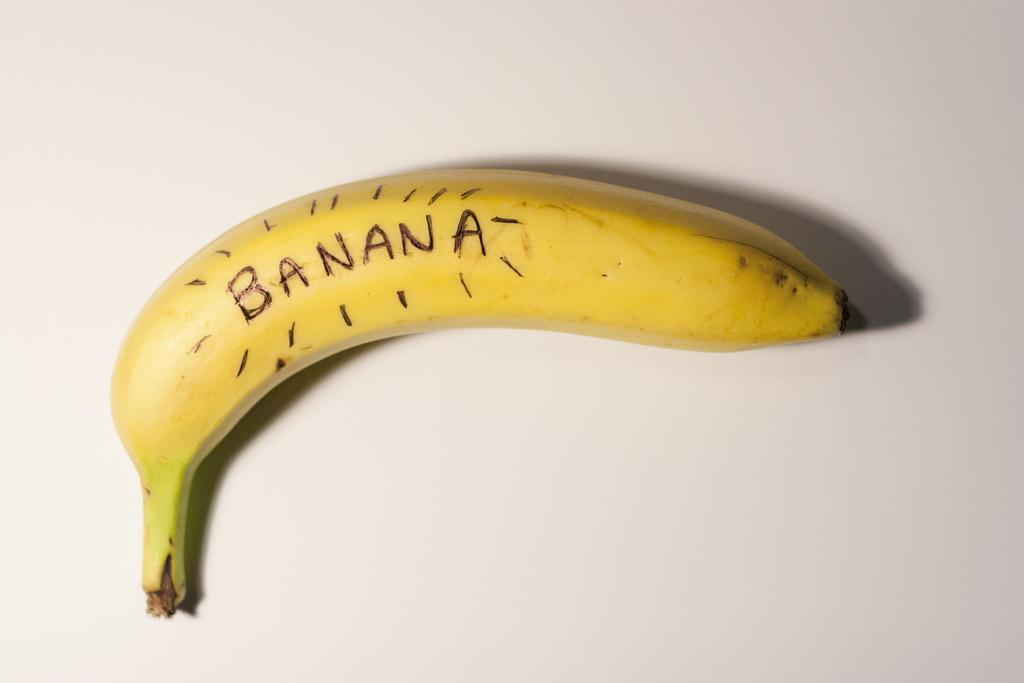<image>
Share a concise interpretation of the image provided. A yellow banana with the word "BANANA" carved into it 